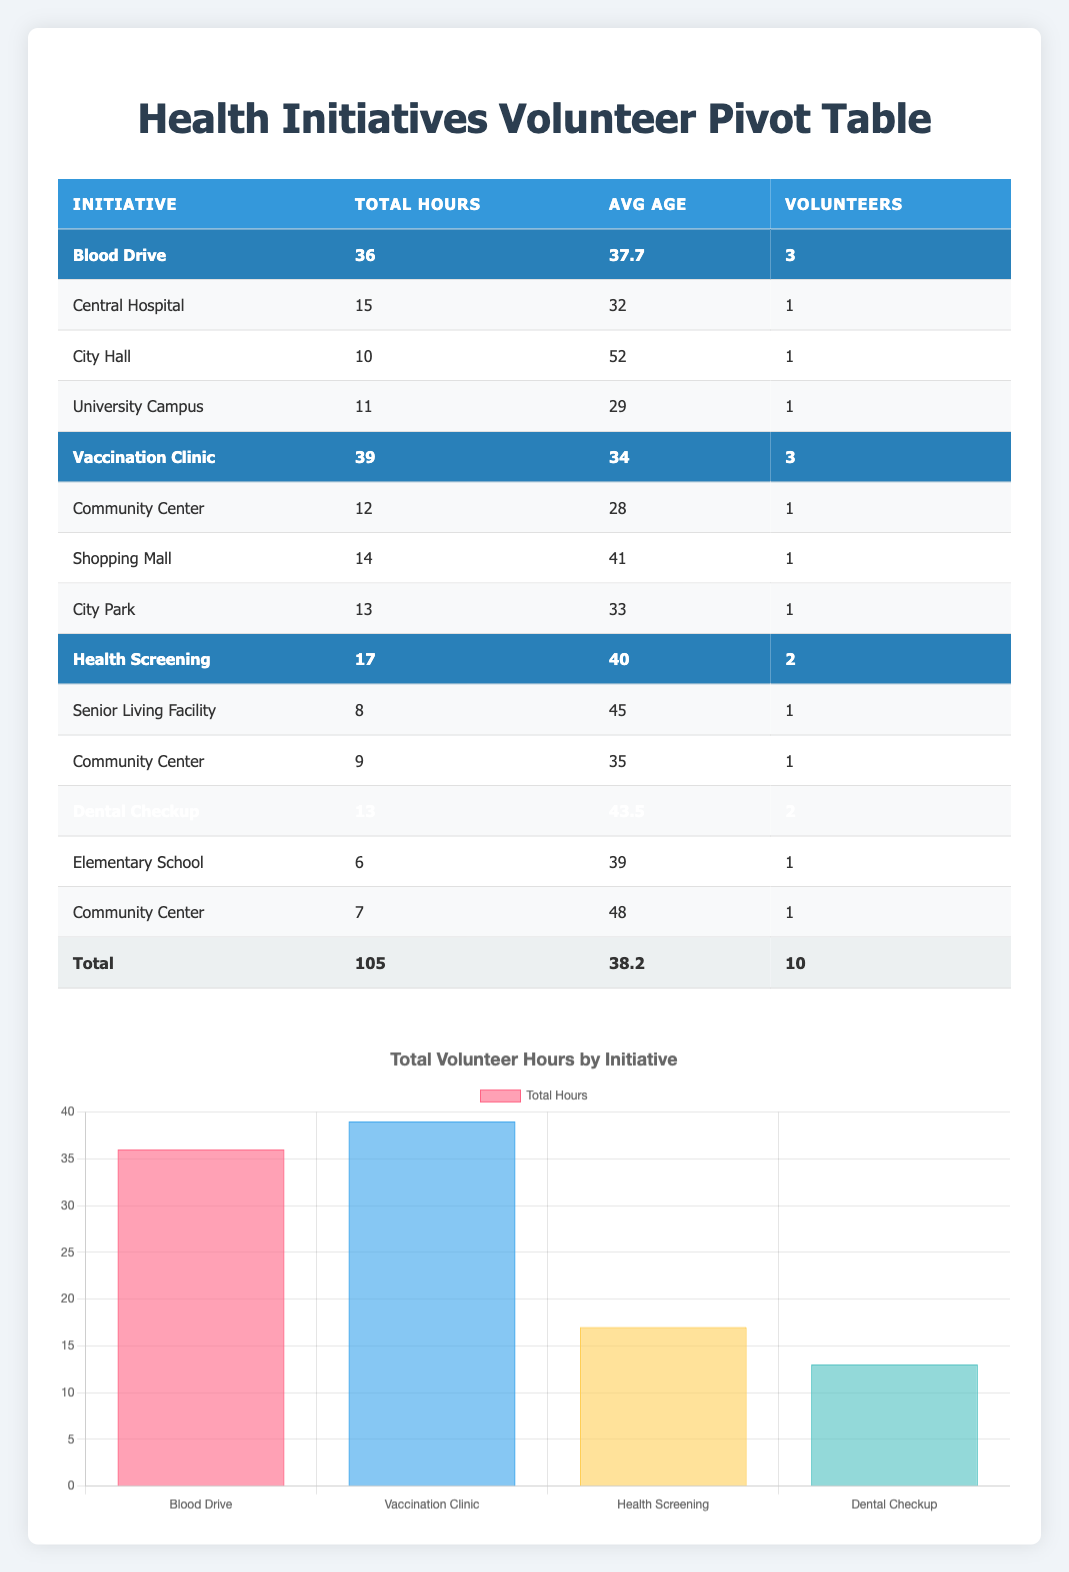What is the total number of volunteer hours logged across all initiatives? The total volunteer hours can be found in the "Total" row of the table. It shows 105 total hours contributed by volunteers across all health initiatives.
Answer: 105 Which initiative had the highest average age of volunteers? To determine which initiative had the highest average age, we compare the average ages listed under each initiative. For Blood Drive it is 37.7, Vaccination Clinic is 34, Health Screening is 40, and Dental Checkup is 43.5. The highest is 43.5 for Dental Checkup.
Answer: Dental Checkup How many volunteers participated in the Blood Drive initiative? The number of volunteers for the Blood Drive can be found in the "Volunteers" column under the Blood Drive initiative. There are 3 volunteers listed: Sarah Johnson, David Thompson, and Robert Lee.
Answer: 3 What is the difference in total hours volunteered between the Vaccination Clinic and the Health Screening initiative? The total hours for Vaccination Clinic is 39, and for Health Screening, it is 17. To find the difference, we calculate 39 - 17 = 22.
Answer: 22 Did more volunteers participate in the Dental Checkup than the Health Screening initiative? Looking at the number of volunteers for each initiative, the Dental Checkup has 2 volunteers while the Health Screening also has 2 volunteers. Therefore, it is false that more volunteers participated in the Dental Checkup.
Answer: No Which location did the most hours of volunteering come from? We need to check the total hours contributed by volunteers from each location. The highest total hours can be calculated as follows: Central Hospital has 15, City Hall has 10, University Campus has 11, Community Center for both Vaccination Clinic and Health Screening adds 12 + 9 = 21, which is the highest contribution. Therefore, the Community Center has the most total hours contributed.
Answer: Community Center What is the average volunteering age of those who participated in the Vaccination Clinic? For the Vaccination Clinic, there are three volunteers: Michael Chen (28), James Wilson (41), and Thomas Martinez (33). To find the average age: (28 + 41 + 33) / 3 = 34.
Answer: 34 How many volunteers contributed more than 10 hours in total? We check the total hours volunteered by each volunteer. Sarah Johnson (15), Michael Chen (12), James Wilson (14), and Robert Lee (11) all contributed more than 10 hours, totaling 4 volunteers.
Answer: 4 What percentage of total volunteer hours were contributed by volunteers in the Blood Drive initiative? The Blood Drive initiative recorded a total of 36 hours. To calculate the percentage of total hours (105), we use the formula: (36 / 105) * 100, which equals approximately 34.29%.
Answer: 34.29% 